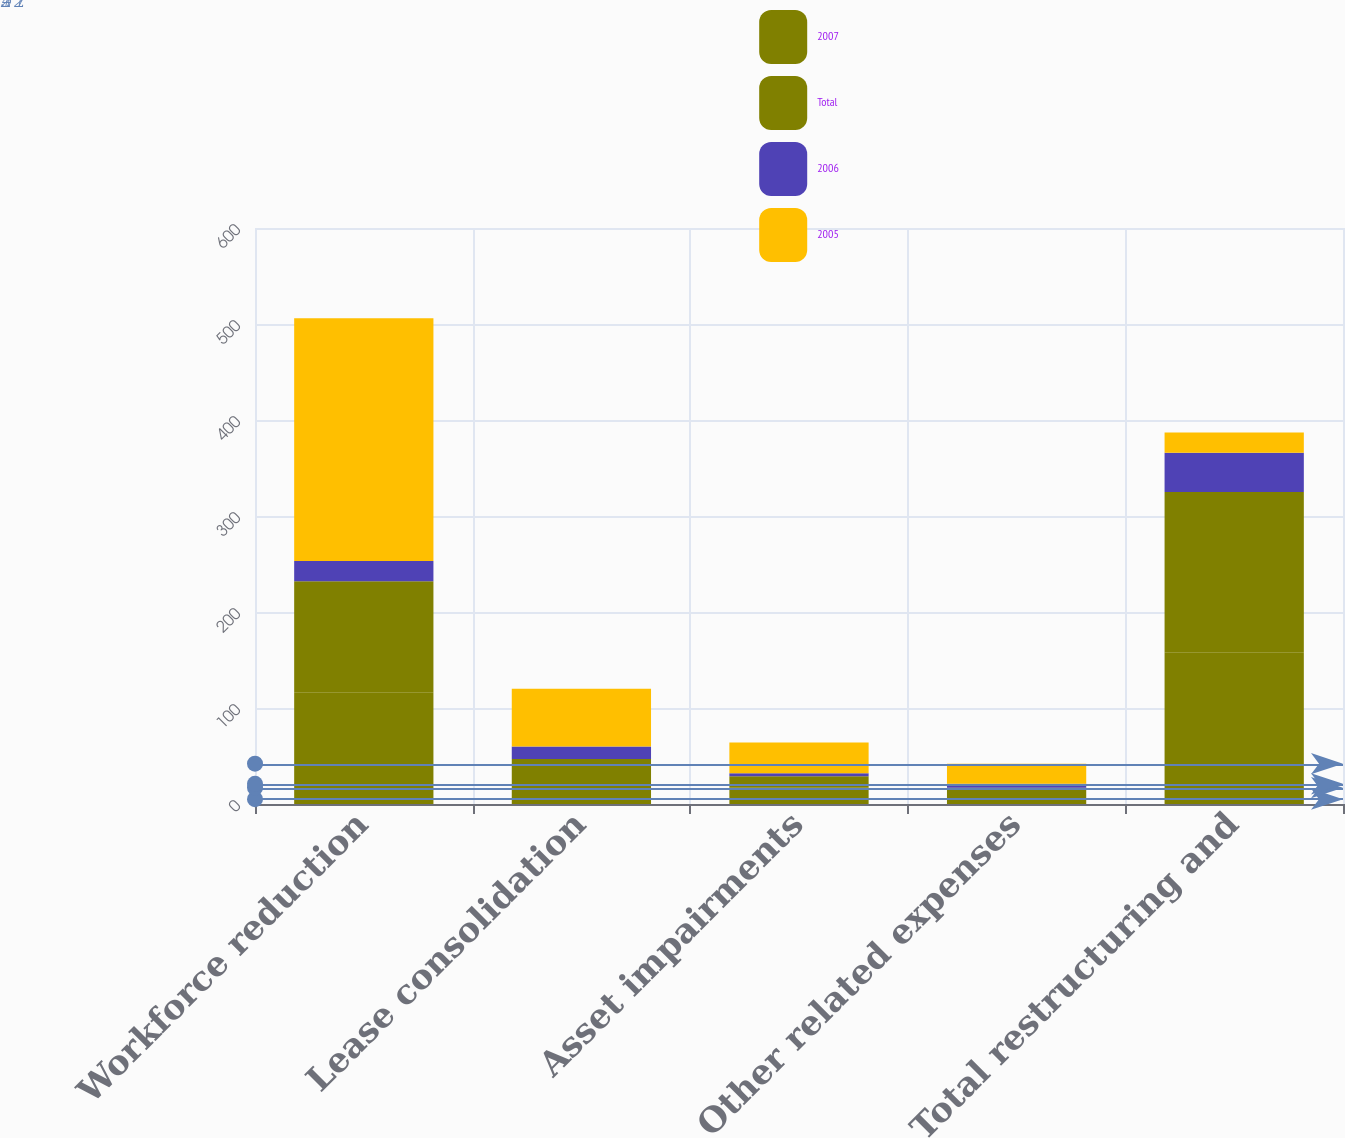<chart> <loc_0><loc_0><loc_500><loc_500><stacked_bar_chart><ecel><fcel>Workforce reduction<fcel>Lease consolidation<fcel>Asset impairments<fcel>Other related expenses<fcel>Total restructuring and<nl><fcel>2007<fcel>116<fcel>20<fcel>17<fcel>5<fcel>158<nl><fcel>Total<fcel>116<fcel>27<fcel>12<fcel>12<fcel>167<nl><fcel>2006<fcel>21<fcel>13<fcel>3<fcel>4<fcel>41<nl><fcel>2005<fcel>253<fcel>60<fcel>32<fcel>21<fcel>21<nl></chart> 